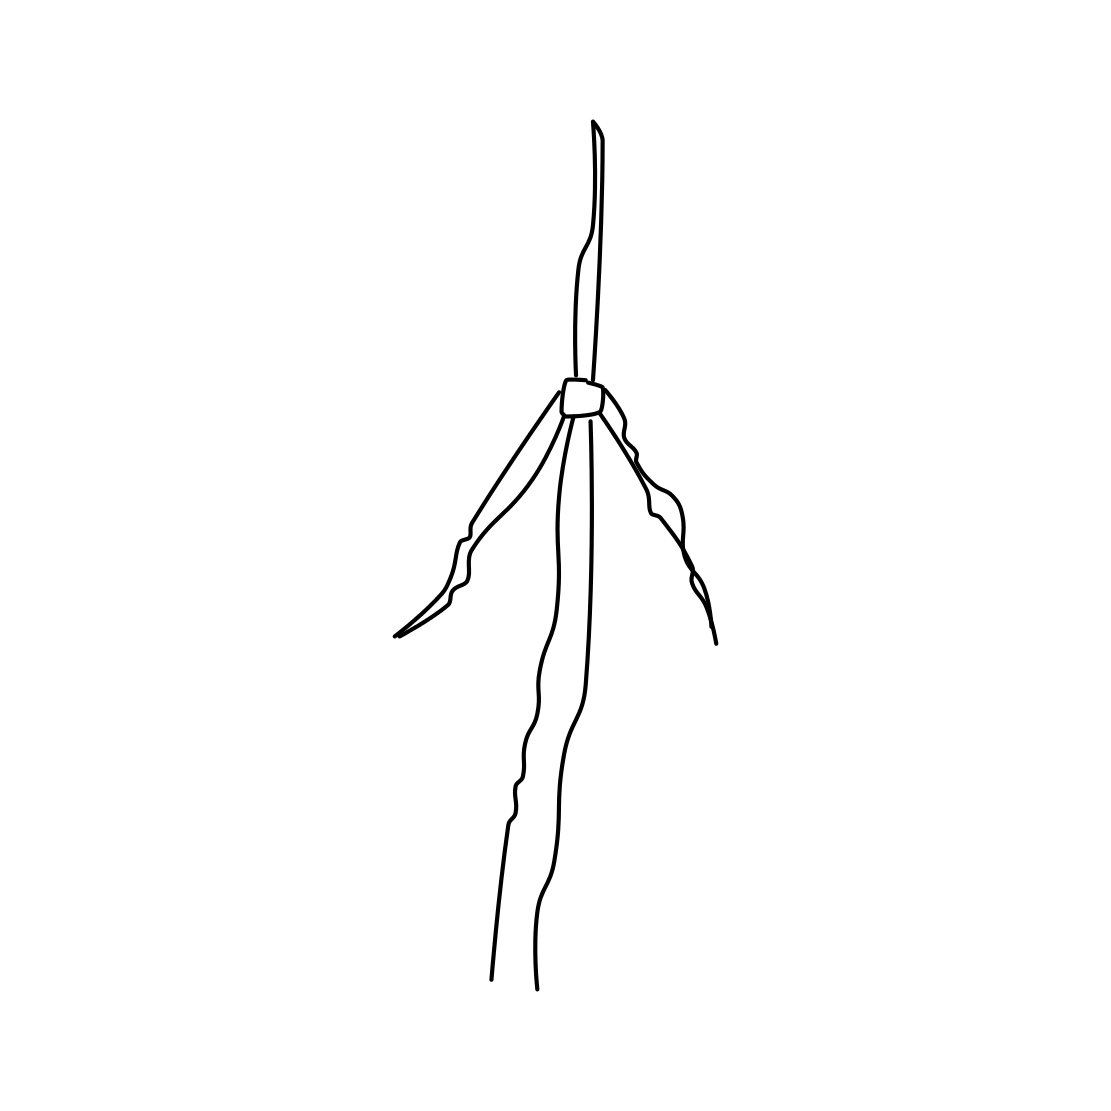Is this a windmill in the image? While the structure in the image has similarities to a windmill, specifically the elongated body and blades that suggest movement or rotation, it's a stylized representation and might not include the detailed mechanics or complete form typically associated with a windmill. 